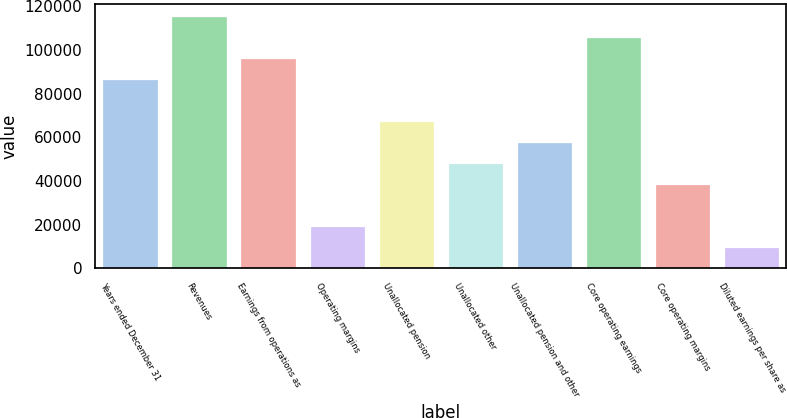<chart> <loc_0><loc_0><loc_500><loc_500><bar_chart><fcel>Years ended December 31<fcel>Revenues<fcel>Earnings from operations as<fcel>Operating margins<fcel>Unallocated pension<fcel>Unallocated other<fcel>Unallocated pension and other<fcel>Core operating earnings<fcel>Core operating margins<fcel>Diluted earnings per share as<nl><fcel>86502.6<fcel>115337<fcel>96114<fcel>19222.9<fcel>67279.9<fcel>48057.1<fcel>57668.5<fcel>105725<fcel>38445.7<fcel>9611.53<nl></chart> 